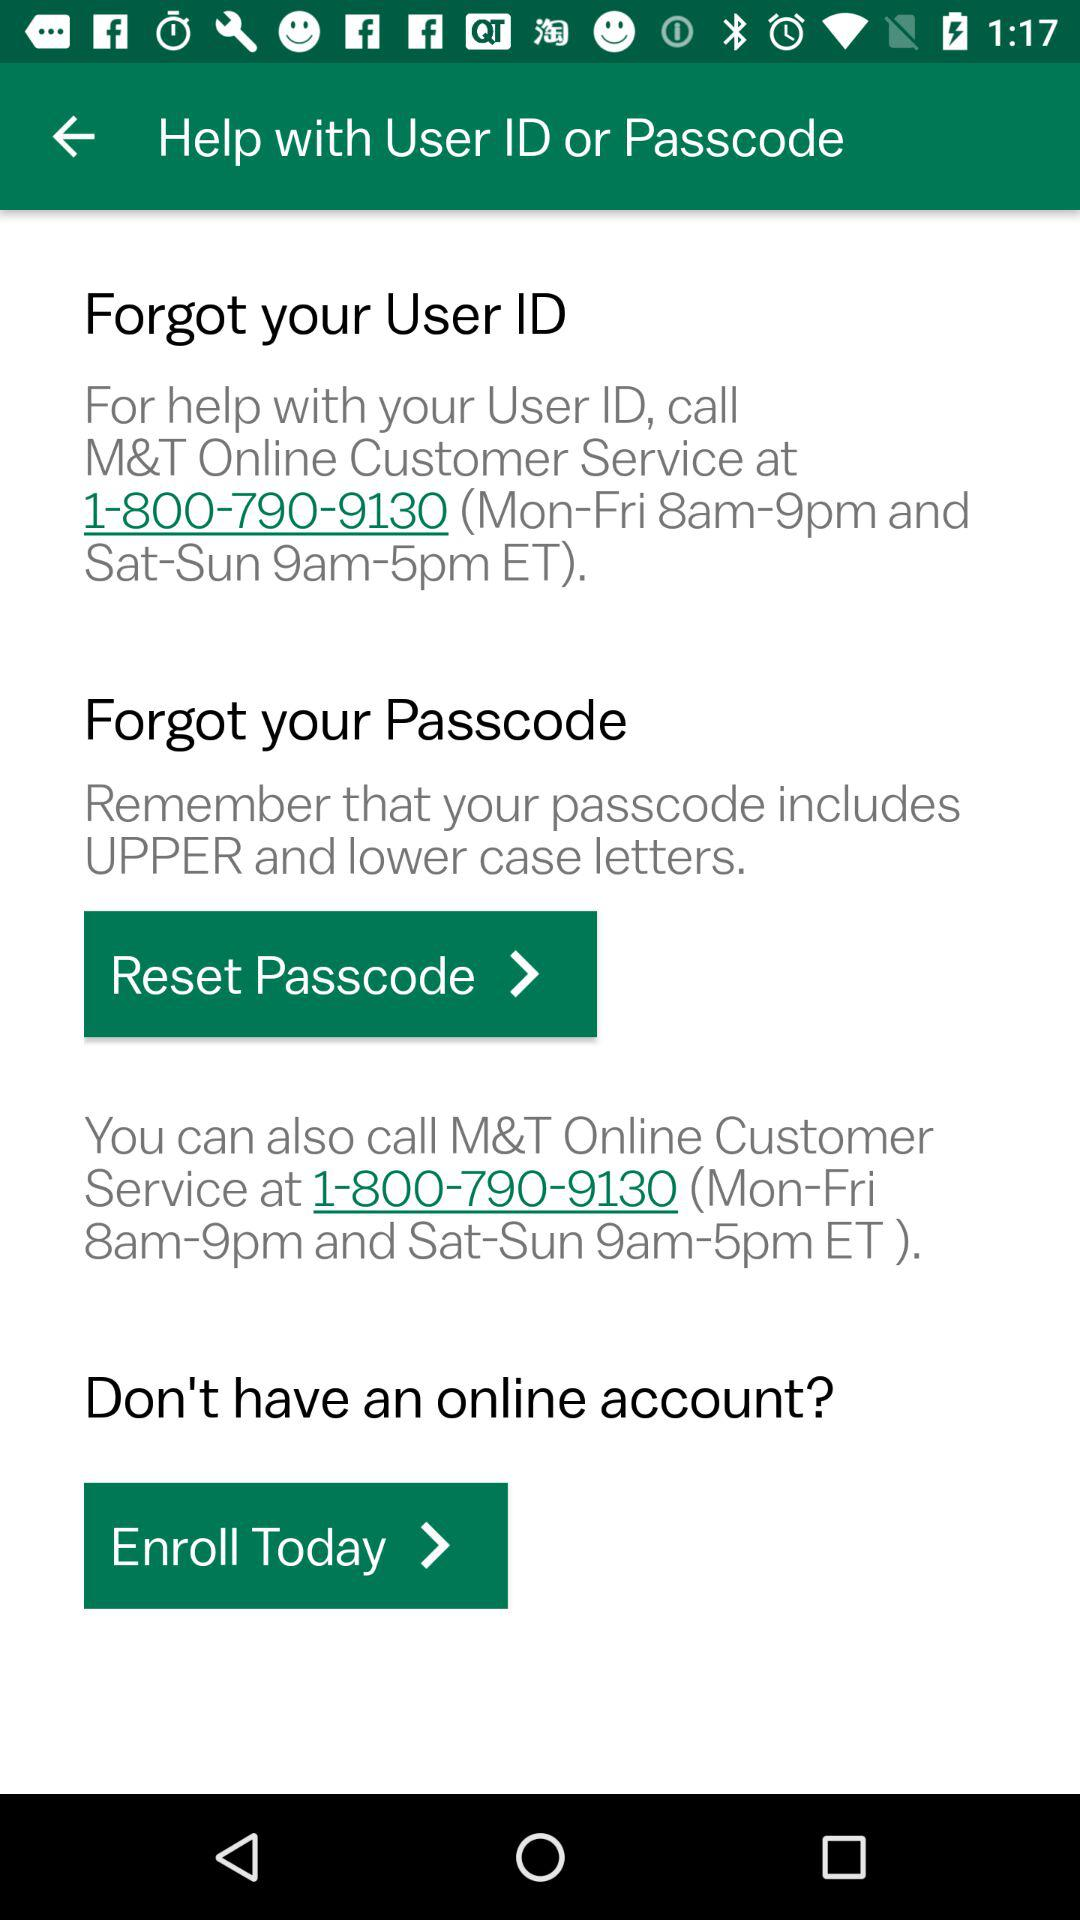What is the timing on the weekend for customer service? The timing on the weekend for customer service is from 9 a.m. to 5 p.m. 